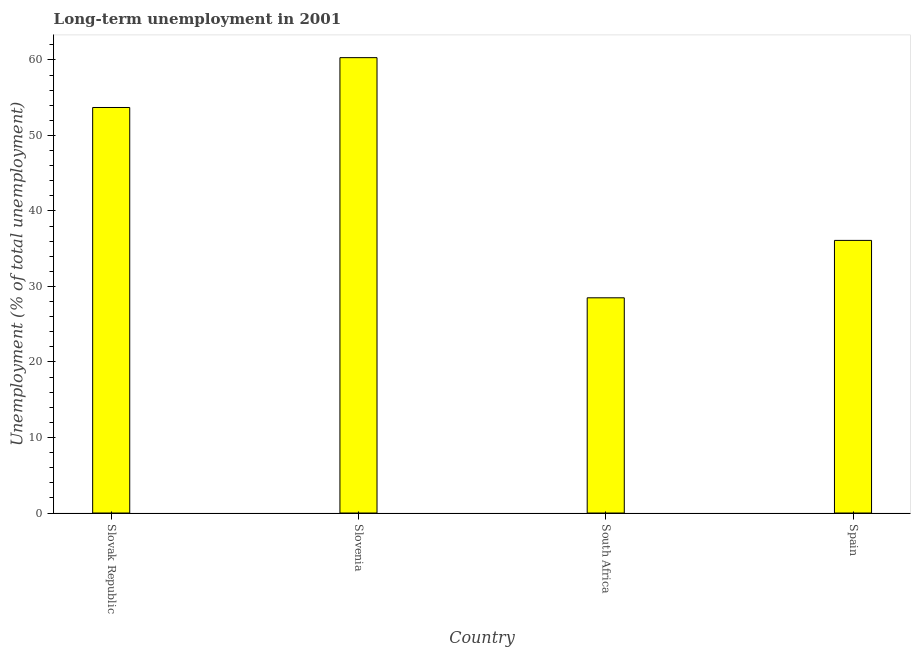Does the graph contain any zero values?
Offer a terse response. No. What is the title of the graph?
Your answer should be compact. Long-term unemployment in 2001. What is the label or title of the X-axis?
Ensure brevity in your answer.  Country. What is the label or title of the Y-axis?
Provide a short and direct response. Unemployment (% of total unemployment). What is the long-term unemployment in Slovenia?
Give a very brief answer. 60.3. Across all countries, what is the maximum long-term unemployment?
Offer a very short reply. 60.3. Across all countries, what is the minimum long-term unemployment?
Offer a very short reply. 28.5. In which country was the long-term unemployment maximum?
Keep it short and to the point. Slovenia. In which country was the long-term unemployment minimum?
Provide a succinct answer. South Africa. What is the sum of the long-term unemployment?
Keep it short and to the point. 178.6. What is the difference between the long-term unemployment in Slovak Republic and Slovenia?
Offer a terse response. -6.6. What is the average long-term unemployment per country?
Your answer should be very brief. 44.65. What is the median long-term unemployment?
Give a very brief answer. 44.9. What is the ratio of the long-term unemployment in Slovak Republic to that in Spain?
Ensure brevity in your answer.  1.49. Is the long-term unemployment in Slovenia less than that in South Africa?
Make the answer very short. No. Is the difference between the long-term unemployment in Slovenia and South Africa greater than the difference between any two countries?
Your response must be concise. Yes. What is the difference between the highest and the second highest long-term unemployment?
Your response must be concise. 6.6. What is the difference between the highest and the lowest long-term unemployment?
Your answer should be compact. 31.8. In how many countries, is the long-term unemployment greater than the average long-term unemployment taken over all countries?
Offer a terse response. 2. How many bars are there?
Provide a succinct answer. 4. Are all the bars in the graph horizontal?
Make the answer very short. No. How many countries are there in the graph?
Provide a short and direct response. 4. What is the difference between two consecutive major ticks on the Y-axis?
Offer a very short reply. 10. Are the values on the major ticks of Y-axis written in scientific E-notation?
Provide a short and direct response. No. What is the Unemployment (% of total unemployment) of Slovak Republic?
Your response must be concise. 53.7. What is the Unemployment (% of total unemployment) of Slovenia?
Make the answer very short. 60.3. What is the Unemployment (% of total unemployment) in Spain?
Provide a succinct answer. 36.1. What is the difference between the Unemployment (% of total unemployment) in Slovak Republic and South Africa?
Provide a succinct answer. 25.2. What is the difference between the Unemployment (% of total unemployment) in Slovak Republic and Spain?
Your answer should be compact. 17.6. What is the difference between the Unemployment (% of total unemployment) in Slovenia and South Africa?
Offer a terse response. 31.8. What is the difference between the Unemployment (% of total unemployment) in Slovenia and Spain?
Keep it short and to the point. 24.2. What is the difference between the Unemployment (% of total unemployment) in South Africa and Spain?
Give a very brief answer. -7.6. What is the ratio of the Unemployment (% of total unemployment) in Slovak Republic to that in Slovenia?
Your answer should be compact. 0.89. What is the ratio of the Unemployment (% of total unemployment) in Slovak Republic to that in South Africa?
Provide a succinct answer. 1.88. What is the ratio of the Unemployment (% of total unemployment) in Slovak Republic to that in Spain?
Provide a short and direct response. 1.49. What is the ratio of the Unemployment (% of total unemployment) in Slovenia to that in South Africa?
Offer a terse response. 2.12. What is the ratio of the Unemployment (% of total unemployment) in Slovenia to that in Spain?
Your response must be concise. 1.67. What is the ratio of the Unemployment (% of total unemployment) in South Africa to that in Spain?
Ensure brevity in your answer.  0.79. 